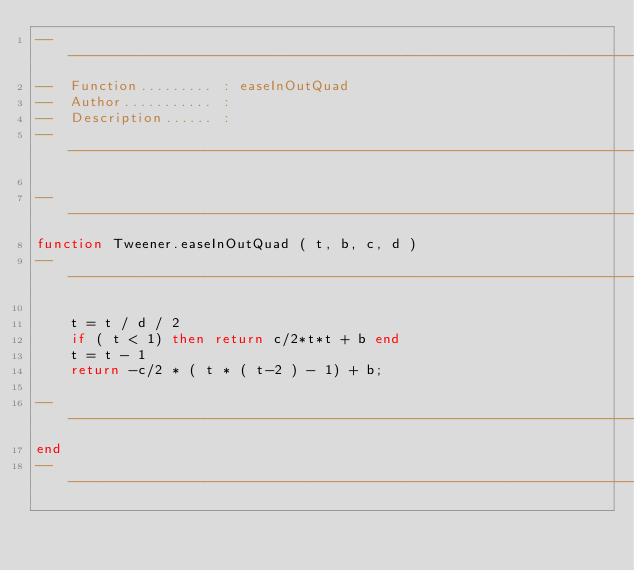<code> <loc_0><loc_0><loc_500><loc_500><_Lua_>--------------------------------------------------------------------------------
--  Function......... : easeInOutQuad
--  Author........... : 
--  Description...... : 
--------------------------------------------------------------------------------

--------------------------------------------------------------------------------
function Tweener.easeInOutQuad ( t, b, c, d )
--------------------------------------------------------------------------------
	
    t = t / d / 2
	if ( t < 1) then return c/2*t*t + b end
    t = t - 1
    return -c/2 * ( t * ( t-2 ) - 1) + b;
	
--------------------------------------------------------------------------------
end
--------------------------------------------------------------------------------
</code> 